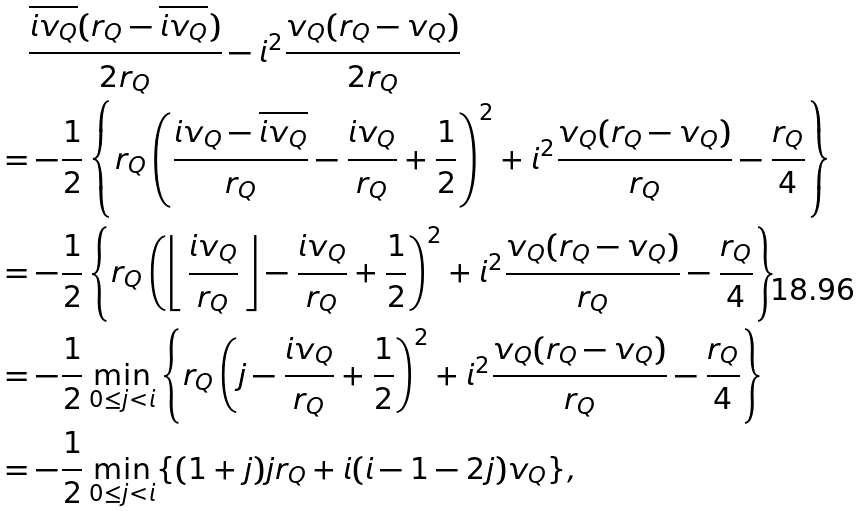<formula> <loc_0><loc_0><loc_500><loc_500>& \quad \frac { \overline { i v _ { Q } } ( r _ { Q } - \overline { i v _ { Q } } ) } { 2 r _ { Q } } - i ^ { 2 } \frac { v _ { Q } ( r _ { Q } - v _ { Q } ) } { 2 r _ { Q } } \\ & = - \frac { 1 } { 2 } \left \{ r _ { Q } \left ( \frac { i v _ { Q } - \overline { i v _ { Q } } } { r _ { Q } } - \frac { i v _ { Q } } { r _ { Q } } + \frac { 1 } { 2 } \right ) ^ { 2 } + i ^ { 2 } \frac { v _ { Q } ( r _ { Q } - v _ { Q } ) } { r _ { Q } } - \frac { r _ { Q } } { 4 } \right \} \\ & = - \frac { 1 } { 2 } \left \{ r _ { Q } \left ( \left \lfloor \, \frac { i v _ { Q } } { r _ { Q } } \, \right \rfloor - \frac { i v _ { Q } } { r _ { Q } } + \frac { 1 } { 2 } \right ) ^ { 2 } + i ^ { 2 } \frac { v _ { Q } ( r _ { Q } - v _ { Q } ) } { r _ { Q } } - \frac { r _ { Q } } { 4 } \right \} \\ & = - \frac { 1 } { 2 } \min _ { 0 \leq j < i } \left \{ r _ { Q } \left ( j - \frac { i v _ { Q } } { r _ { Q } } + \frac { 1 } { 2 } \right ) ^ { 2 } + i ^ { 2 } \frac { v _ { Q } ( r _ { Q } - v _ { Q } ) } { r _ { Q } } - \frac { r _ { Q } } { 4 } \right \} \\ & = - \frac { 1 } { 2 } \min _ { 0 \leq j < i } \{ ( 1 + j ) j r _ { Q } + i ( i - 1 - 2 j ) v _ { Q } \} ,</formula> 